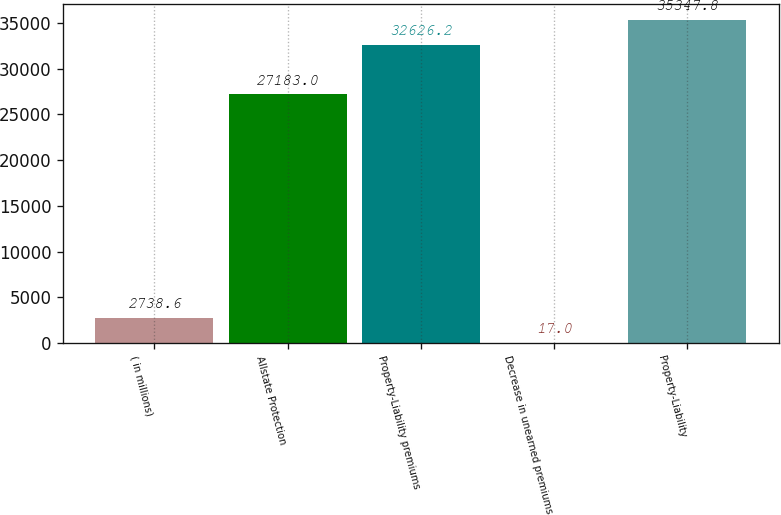Convert chart. <chart><loc_0><loc_0><loc_500><loc_500><bar_chart><fcel>( in millions)<fcel>Allstate Protection<fcel>Property-Liability premiums<fcel>Decrease in unearned premiums<fcel>Property-Liability<nl><fcel>2738.6<fcel>27183<fcel>32626.2<fcel>17<fcel>35347.8<nl></chart> 